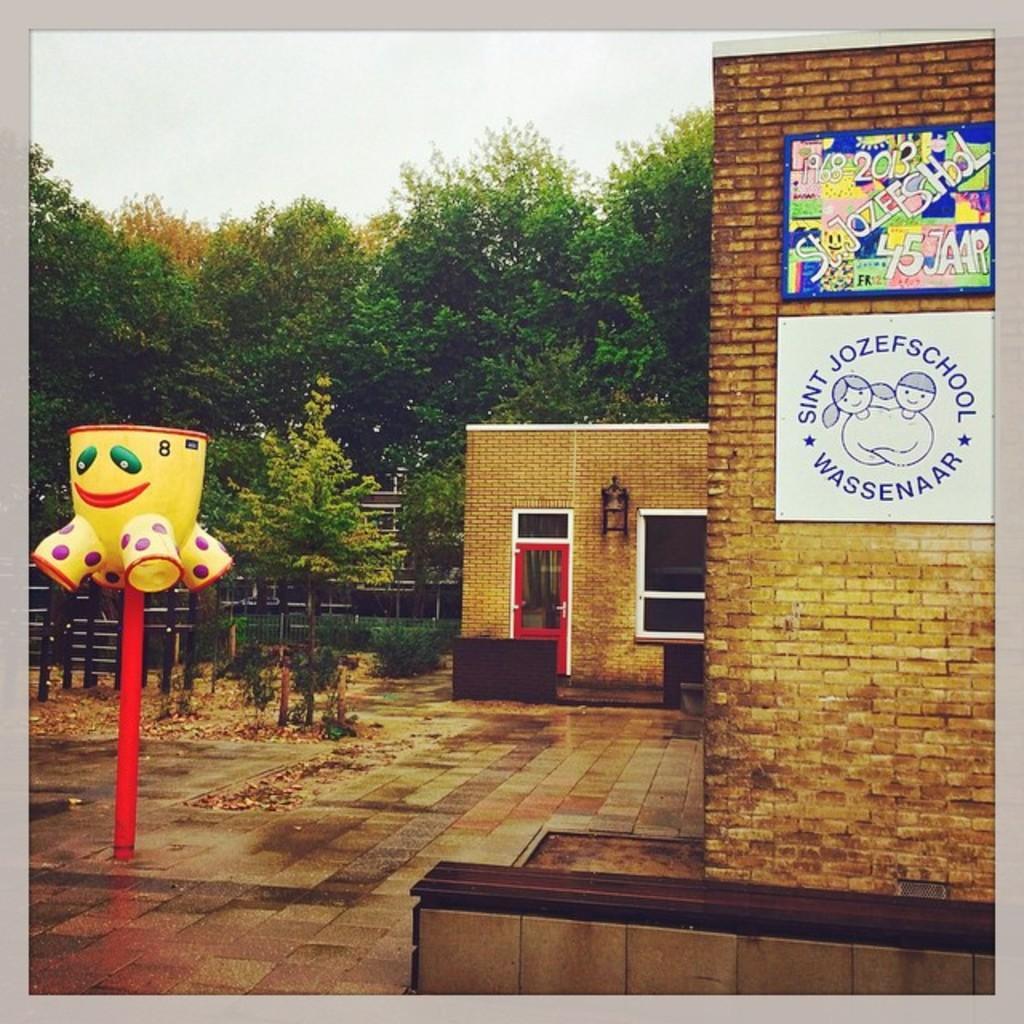How would you summarize this image in a sentence or two? In this image we can see a building with a door, window and some boards on a wall with some text on it. On the left side we can see an object on the pole. On the backside we can see a fence, a group of trees and the sky which looks cloudy. 